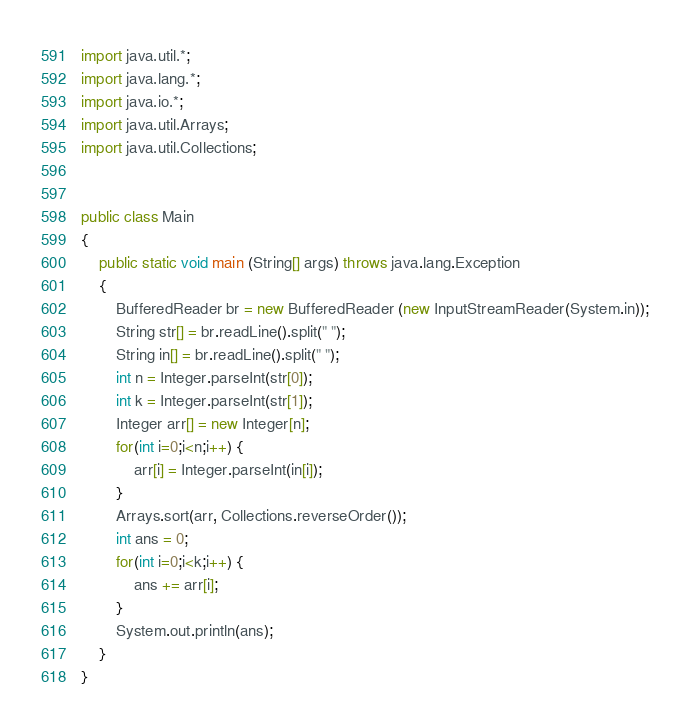<code> <loc_0><loc_0><loc_500><loc_500><_Java_>

import java.util.*;
import java.lang.*;
import java.io.*;
import java.util.Arrays;
import java.util.Collections;


public class Main
{
	public static void main (String[] args) throws java.lang.Exception
	{
		BufferedReader br = new BufferedReader (new InputStreamReader(System.in));
		String str[] = br.readLine().split(" ");
		String in[] = br.readLine().split(" ");
		int n = Integer.parseInt(str[0]);
		int k = Integer.parseInt(str[1]);
		Integer arr[] = new Integer[n];
		for(int i=0;i<n;i++) {
		    arr[i] = Integer.parseInt(in[i]);
		}
		Arrays.sort(arr, Collections.reverseOrder());
		int ans = 0;
		for(int i=0;i<k;i++) {
		    ans += arr[i];
		}
		System.out.println(ans);
	}
}
</code> 